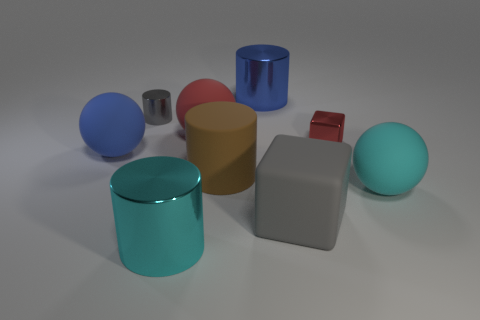Subtract all red rubber spheres. How many spheres are left? 2 Subtract all gray cubes. How many cubes are left? 1 Subtract 3 cylinders. How many cylinders are left? 1 Subtract all blocks. How many objects are left? 7 Subtract all green cubes. Subtract all brown balls. How many cubes are left? 2 Subtract all matte objects. Subtract all large matte cubes. How many objects are left? 3 Add 4 balls. How many balls are left? 7 Add 1 tiny matte things. How many tiny matte things exist? 1 Subtract 1 brown cylinders. How many objects are left? 8 